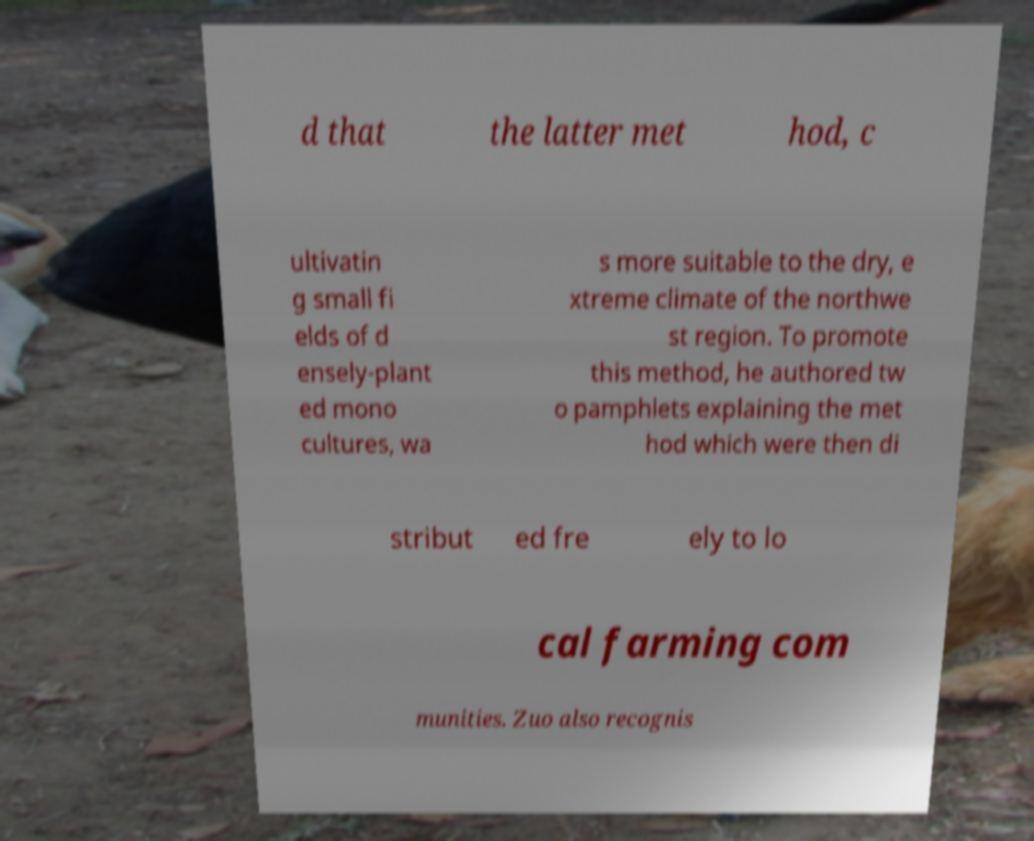Please read and relay the text visible in this image. What does it say? d that the latter met hod, c ultivatin g small fi elds of d ensely-plant ed mono cultures, wa s more suitable to the dry, e xtreme climate of the northwe st region. To promote this method, he authored tw o pamphlets explaining the met hod which were then di stribut ed fre ely to lo cal farming com munities. Zuo also recognis 